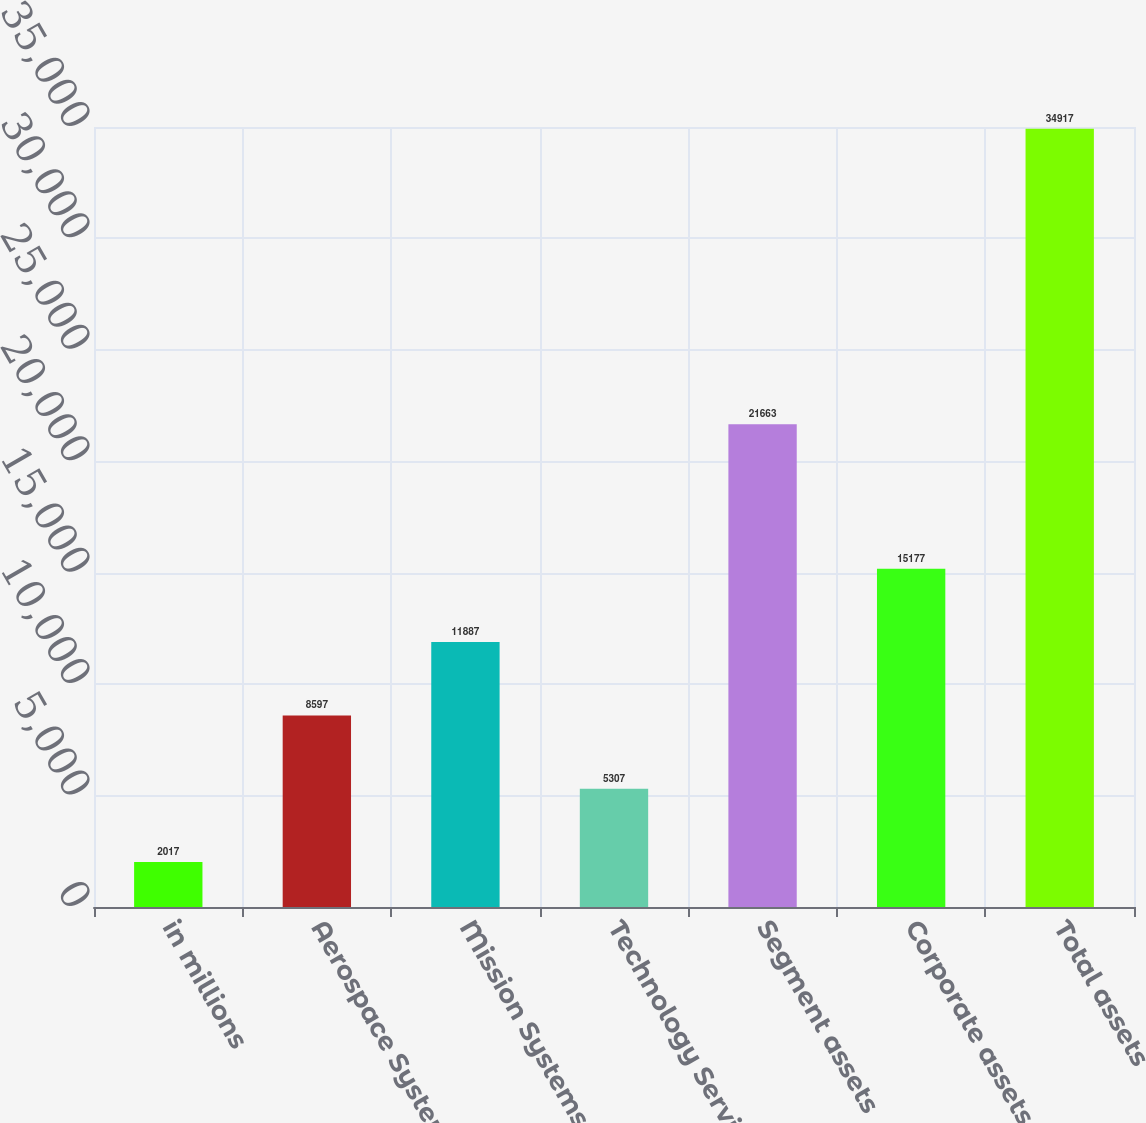<chart> <loc_0><loc_0><loc_500><loc_500><bar_chart><fcel>in millions<fcel>Aerospace Systems<fcel>Mission Systems<fcel>Technology Services<fcel>Segment assets<fcel>Corporate assets (1)<fcel>Total assets<nl><fcel>2017<fcel>8597<fcel>11887<fcel>5307<fcel>21663<fcel>15177<fcel>34917<nl></chart> 